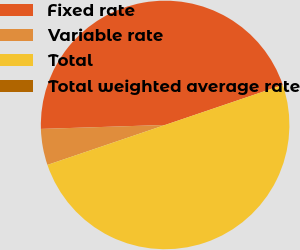Convert chart. <chart><loc_0><loc_0><loc_500><loc_500><pie_chart><fcel>Fixed rate<fcel>Variable rate<fcel>Total<fcel>Total weighted average rate<nl><fcel>45.3%<fcel>4.7%<fcel>50.0%<fcel>0.0%<nl></chart> 